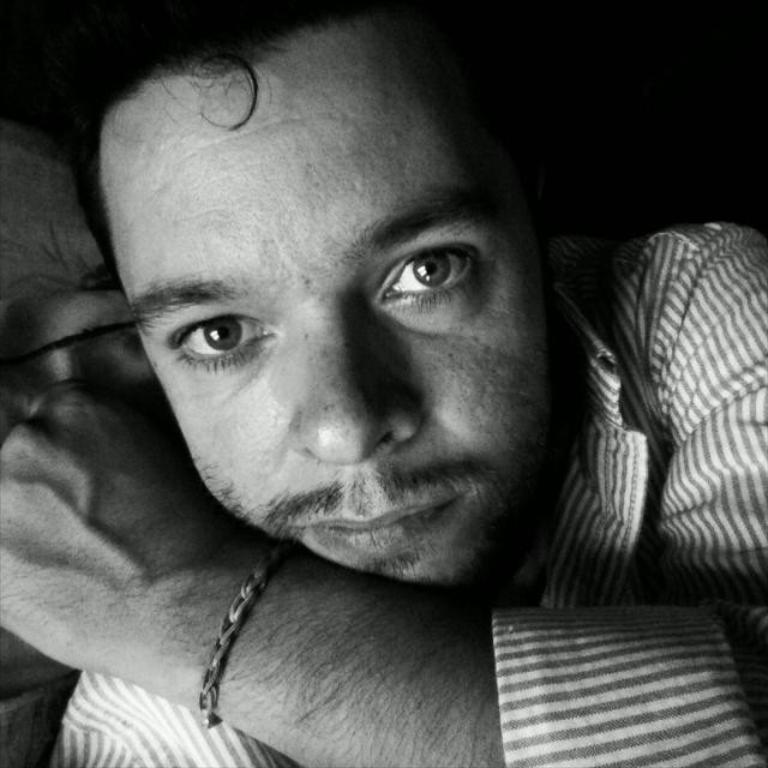What is the main subject in the image? There is a person in the image. What type of neck can be seen on the things in the image? There are no things present in the image, and therefore no necks can be observed. 